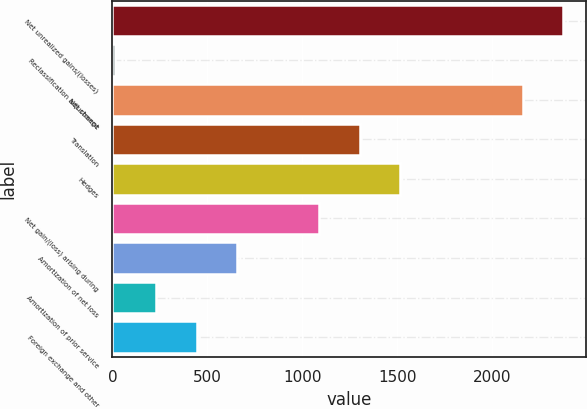Convert chart to OTSL. <chart><loc_0><loc_0><loc_500><loc_500><bar_chart><fcel>Net unrealized gains/(losses)<fcel>Reclassification adjustment<fcel>Net change<fcel>Translation<fcel>Hedges<fcel>Net gain/(loss) arising during<fcel>Amortization of net loss<fcel>Amortization of prior service<fcel>Foreign exchange and other<nl><fcel>2374.6<fcel>14<fcel>2160<fcel>1301.6<fcel>1516.2<fcel>1087<fcel>657.8<fcel>228.6<fcel>443.2<nl></chart> 